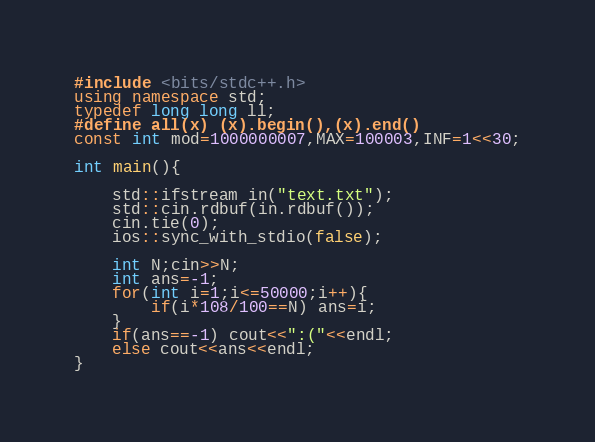Convert code to text. <code><loc_0><loc_0><loc_500><loc_500><_C++_>#include <bits/stdc++.h>
using namespace std;
typedef long long ll;
#define all(x) (x).begin(),(x).end()
const int mod=1000000007,MAX=100003,INF=1<<30;

int main(){
    
    std::ifstream in("text.txt");
    std::cin.rdbuf(in.rdbuf());
    cin.tie(0);
    ios::sync_with_stdio(false);
    
    int N;cin>>N;
    int ans=-1;
    for(int i=1;i<=50000;i++){
        if(i*108/100==N) ans=i;
    }
    if(ans==-1) cout<<":("<<endl;
    else cout<<ans<<endl;
}
</code> 